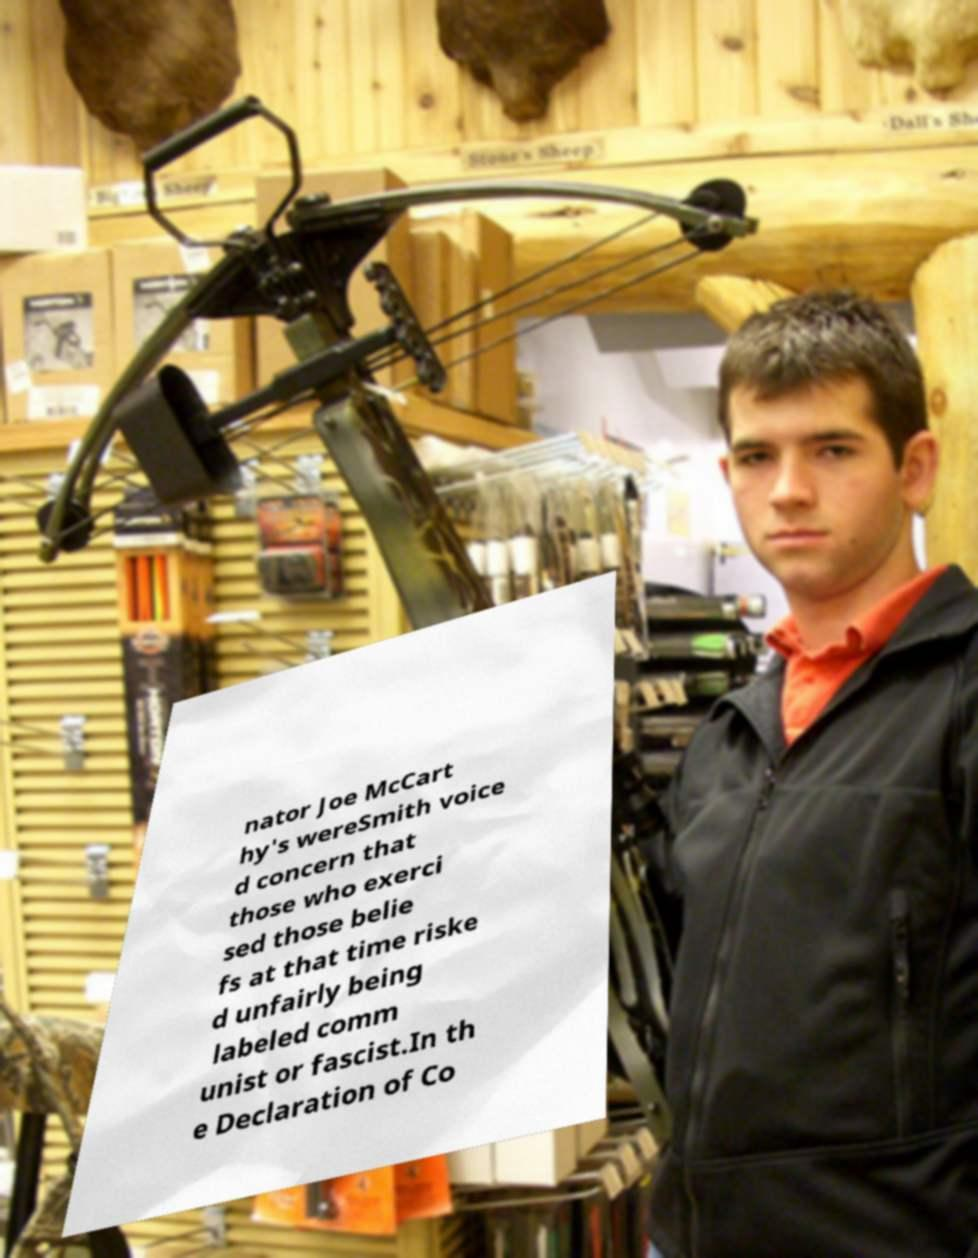Could you extract and type out the text from this image? nator Joe McCart hy's wereSmith voice d concern that those who exerci sed those belie fs at that time riske d unfairly being labeled comm unist or fascist.In th e Declaration of Co 